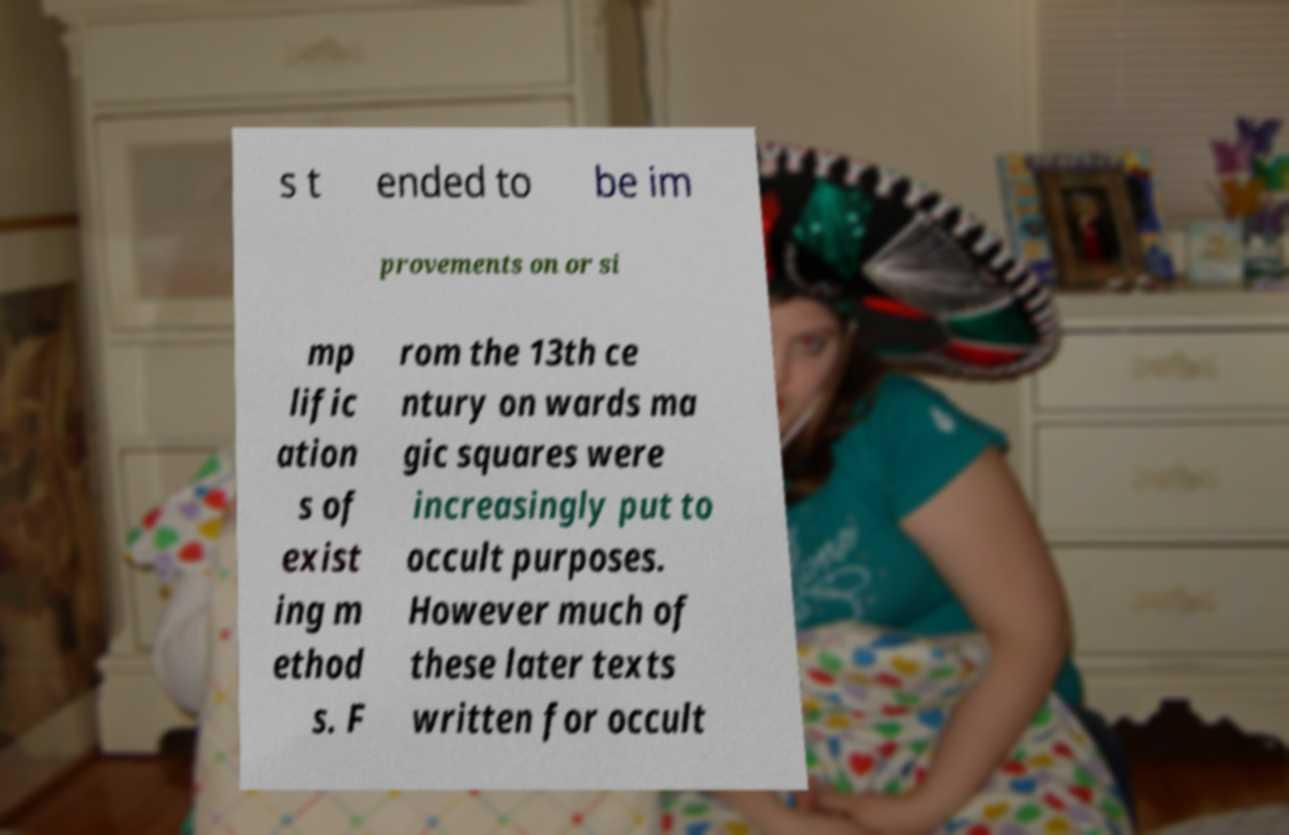Please identify and transcribe the text found in this image. s t ended to be im provements on or si mp lific ation s of exist ing m ethod s. F rom the 13th ce ntury on wards ma gic squares were increasingly put to occult purposes. However much of these later texts written for occult 